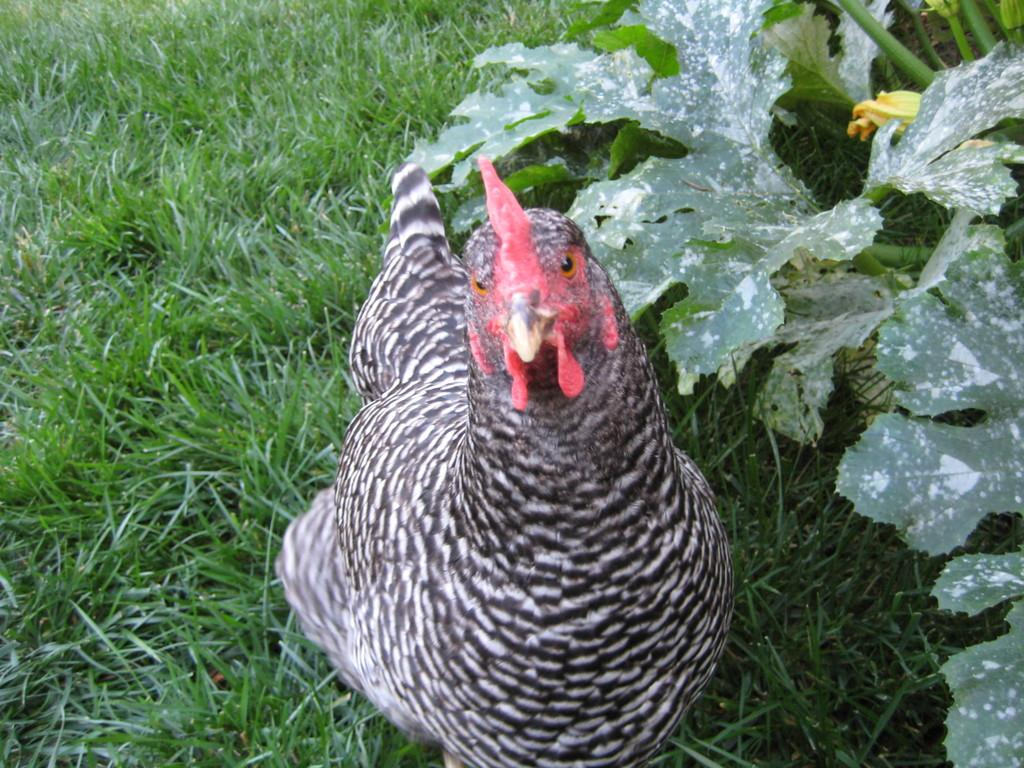What is: What type of plant and flower can be seen on the right side of the picture? There is a plant and flower on the right side of the picture. What animal is in the center of the picture? There is a hen in the center of the picture. What type of vegetation is visible in the picture? There is grass visible in the picture. What type of band is playing music in the background of the picture? There is no band present in the picture, so it is not possible to determine what type of band might be playing music. 